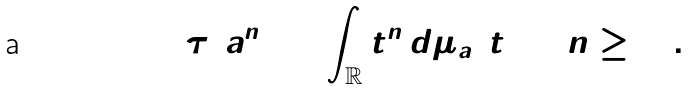<formula> <loc_0><loc_0><loc_500><loc_500>\tau ( a ^ { n } ) = \int _ { \mathbb { R } } t ^ { n } \, d \mu _ { a } ( t ) \quad ( n \geq 1 ) .</formula> 